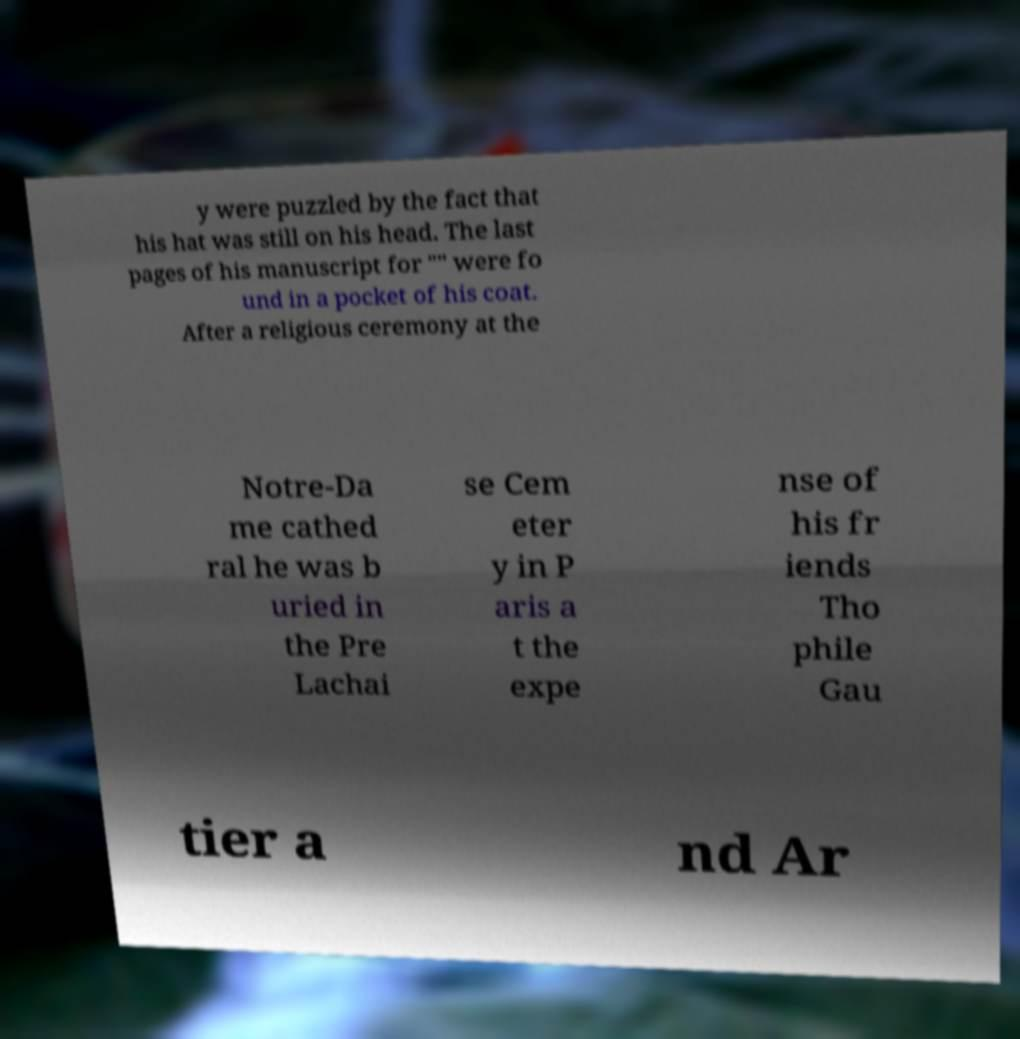For documentation purposes, I need the text within this image transcribed. Could you provide that? y were puzzled by the fact that his hat was still on his head. The last pages of his manuscript for "" were fo und in a pocket of his coat. After a religious ceremony at the Notre-Da me cathed ral he was b uried in the Pre Lachai se Cem eter y in P aris a t the expe nse of his fr iends Tho phile Gau tier a nd Ar 